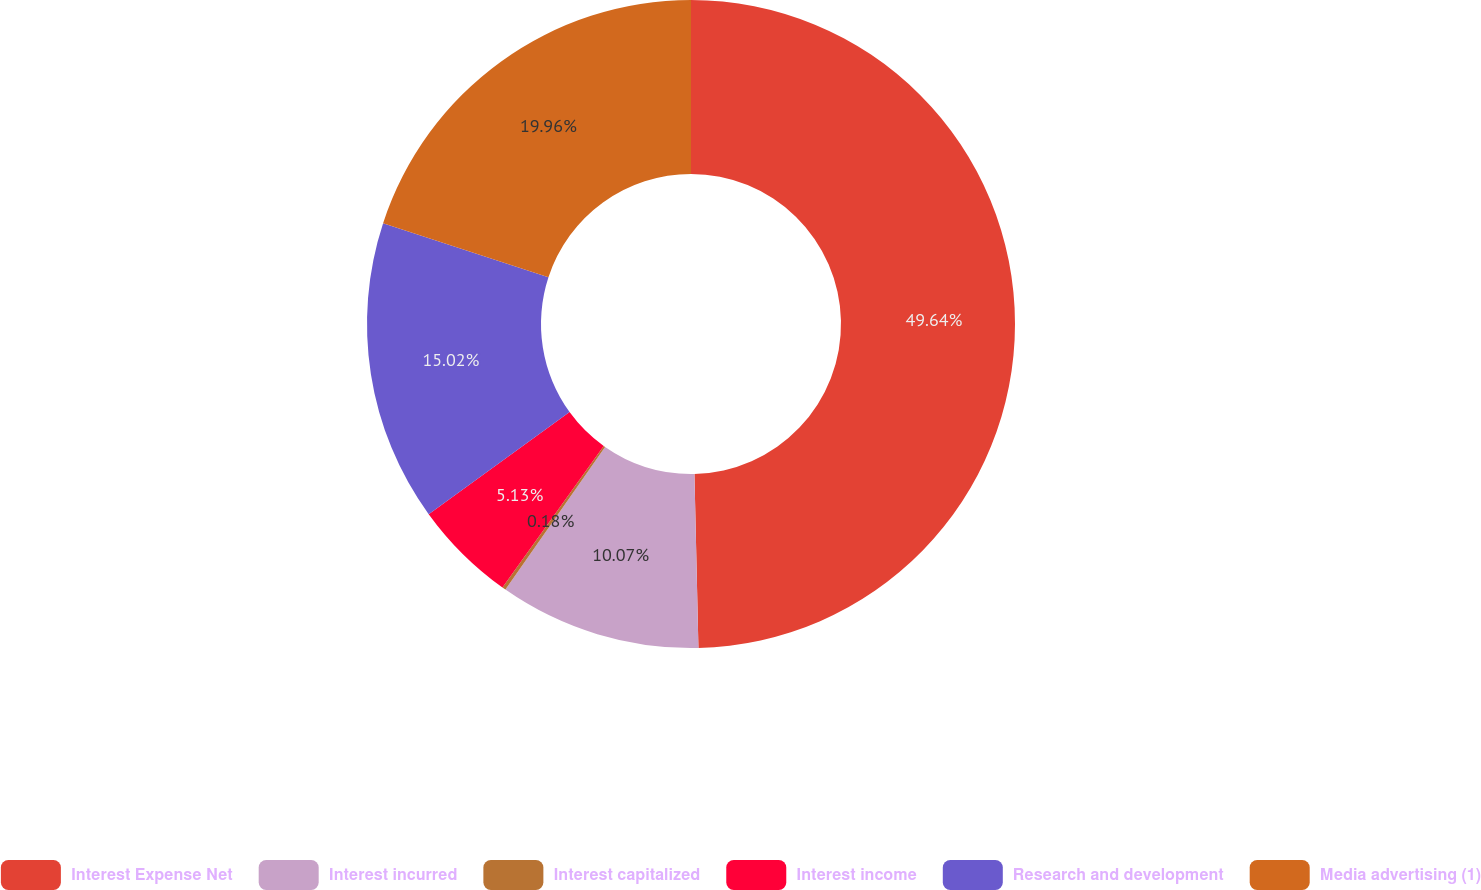Convert chart. <chart><loc_0><loc_0><loc_500><loc_500><pie_chart><fcel>Interest Expense Net<fcel>Interest incurred<fcel>Interest capitalized<fcel>Interest income<fcel>Research and development<fcel>Media advertising (1)<nl><fcel>49.63%<fcel>10.07%<fcel>0.18%<fcel>5.13%<fcel>15.02%<fcel>19.96%<nl></chart> 